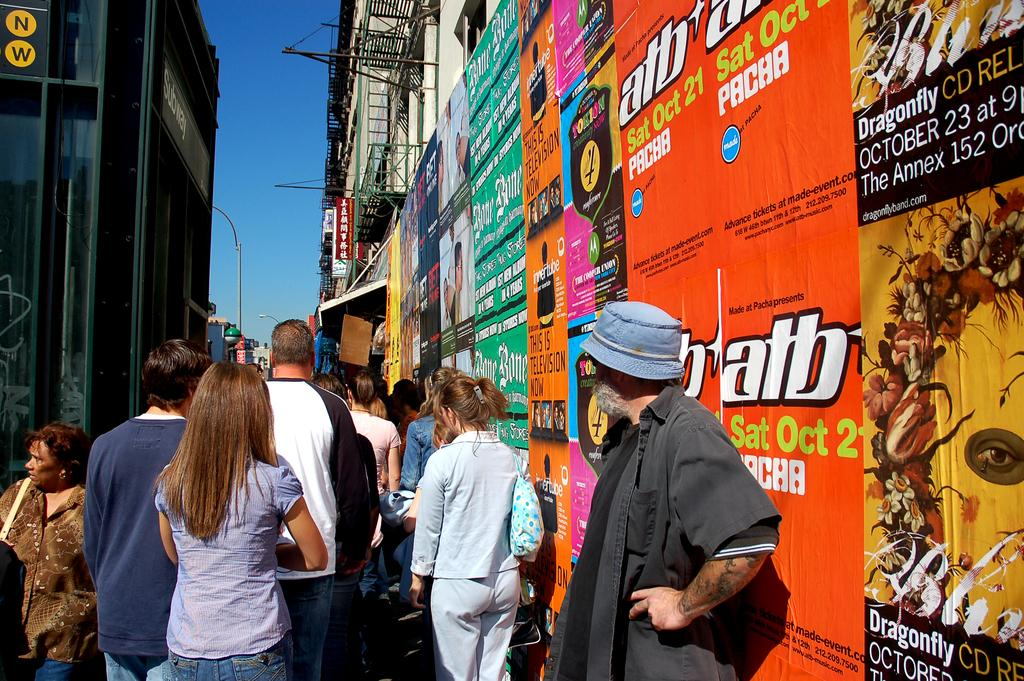How many people are present in the image? There are many people in the image. What are the people doing in the image? The people are moving in a lane. What can be seen on the left side of a wall in the image? There are advertisement posters on the left side of a wall in the image. Can you see a hill in the image? There is no hill present in the image. 